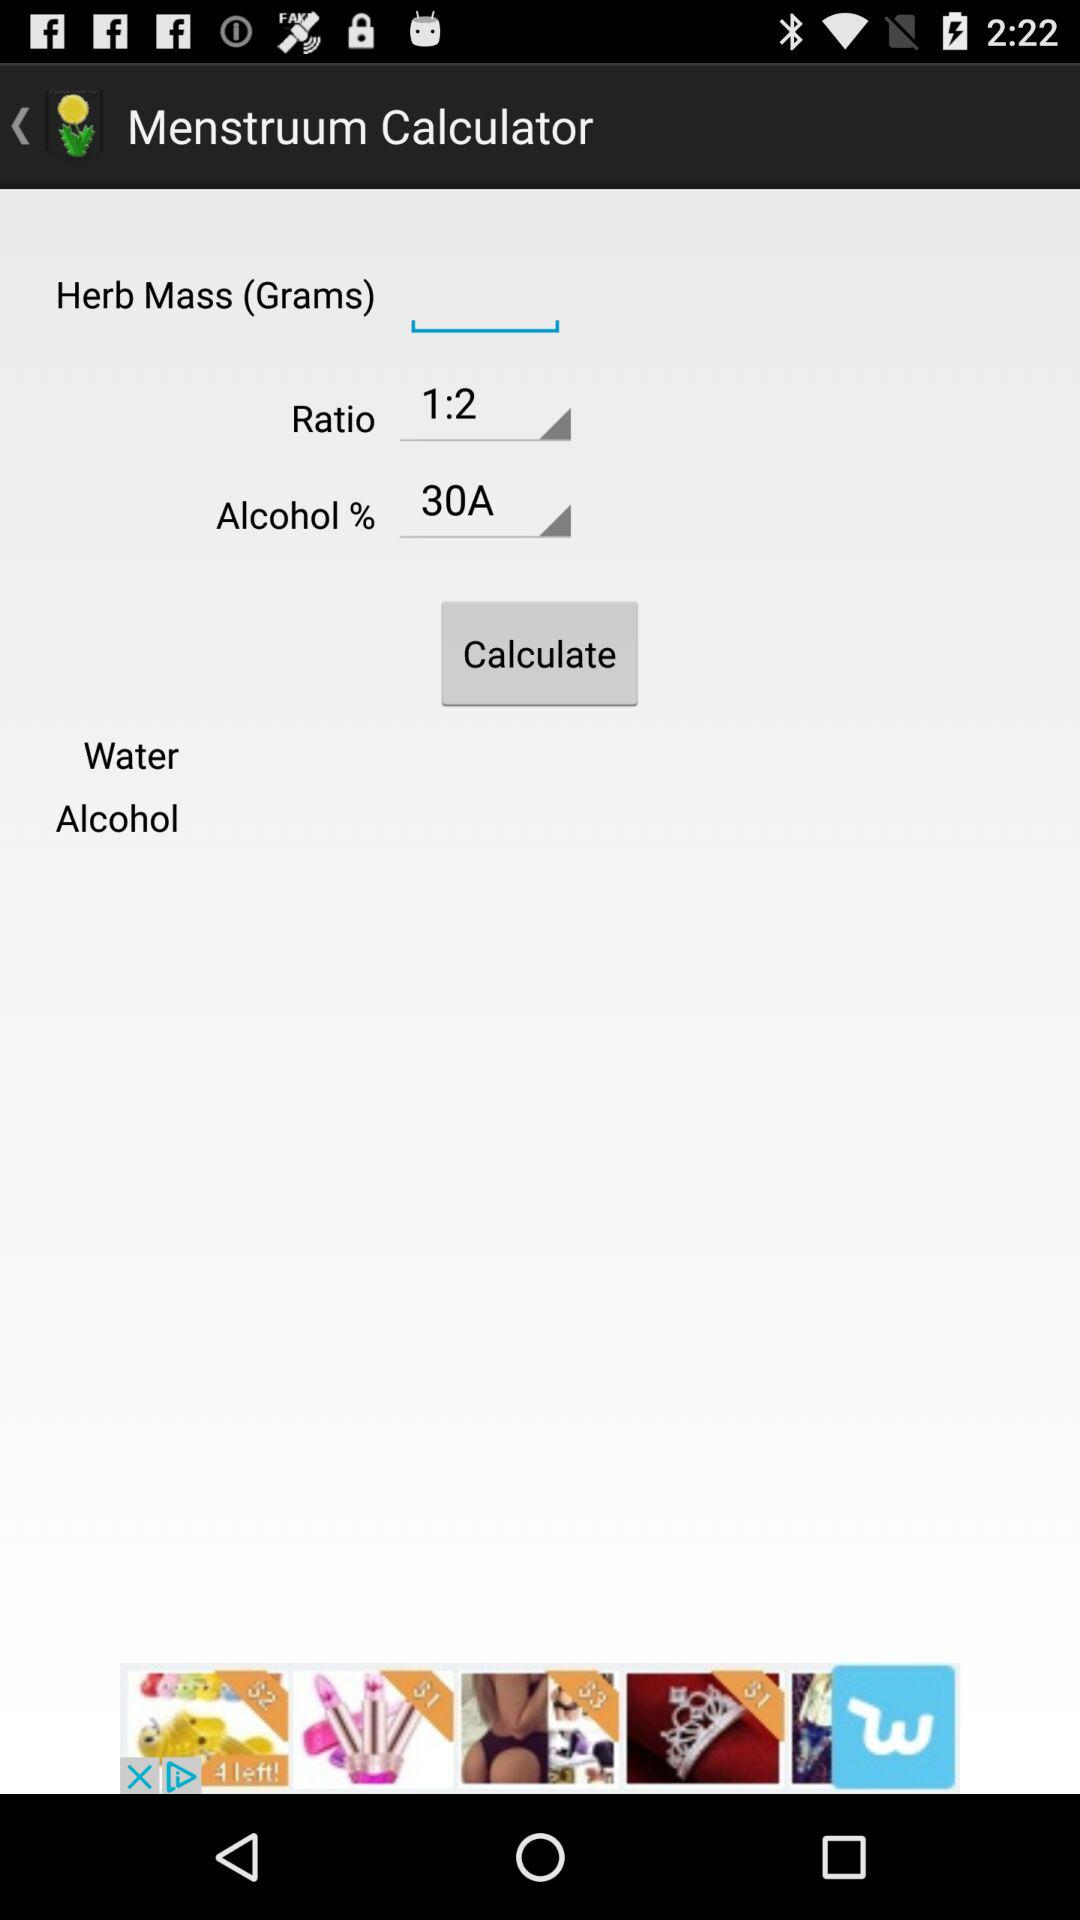What is the application name?
When the provided information is insufficient, respond with <no answer>. <no answer> 